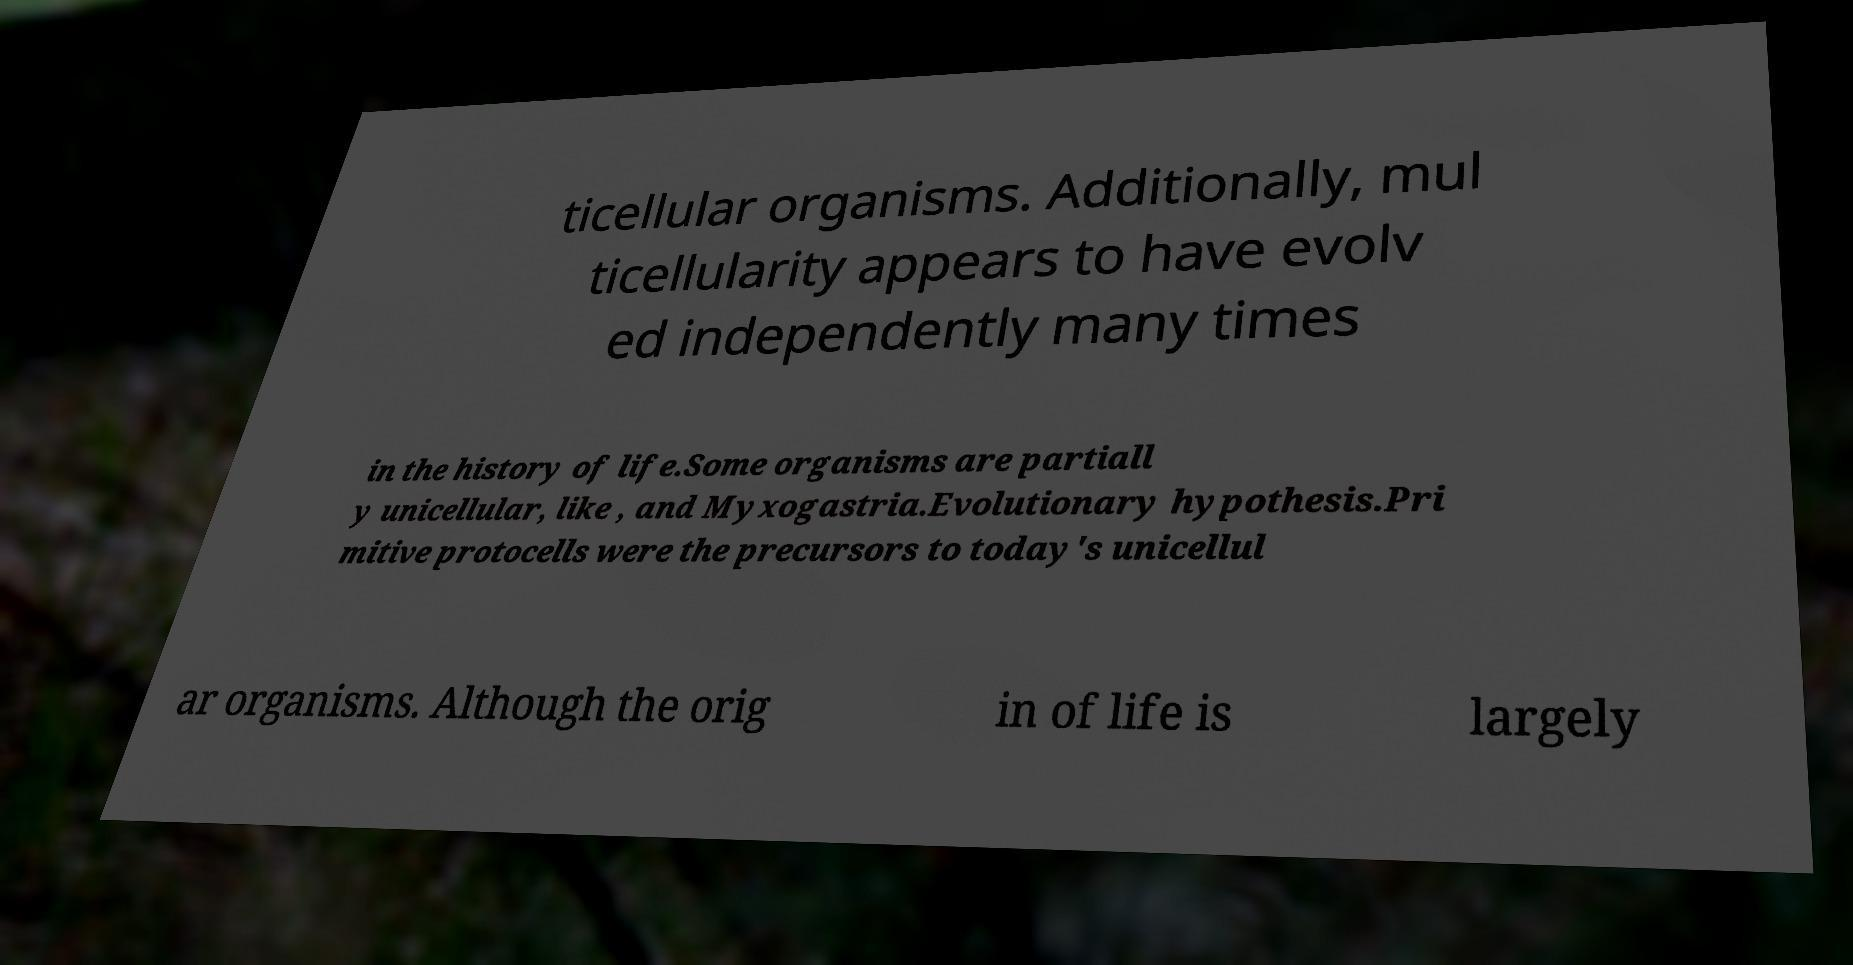I need the written content from this picture converted into text. Can you do that? ticellular organisms. Additionally, mul ticellularity appears to have evolv ed independently many times in the history of life.Some organisms are partiall y unicellular, like , and Myxogastria.Evolutionary hypothesis.Pri mitive protocells were the precursors to today's unicellul ar organisms. Although the orig in of life is largely 